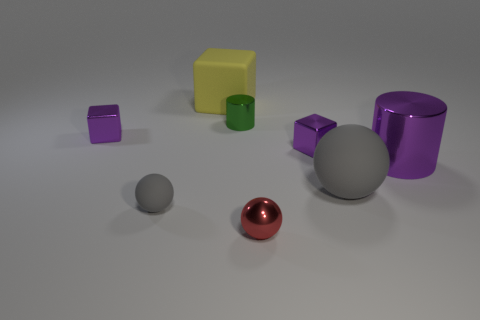Subtract all shiny cubes. How many cubes are left? 1 Add 2 purple metallic things. How many objects exist? 10 Subtract all purple blocks. How many blocks are left? 1 Subtract 2 blocks. How many blocks are left? 1 Subtract all cylinders. How many objects are left? 6 Subtract all gray cylinders. How many yellow blocks are left? 1 Subtract all green spheres. Subtract all matte blocks. How many objects are left? 7 Add 1 big purple objects. How many big purple objects are left? 2 Add 5 large yellow rubber objects. How many large yellow rubber objects exist? 6 Subtract 1 purple cylinders. How many objects are left? 7 